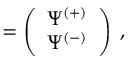Convert formula to latex. <formula><loc_0><loc_0><loc_500><loc_500>{ \Psi } = \left ( \begin{array} { c } { { \Psi ^ { ( + ) } } } \\ { { \Psi ^ { ( - ) } } } \end{array} \right ) \, ,</formula> 